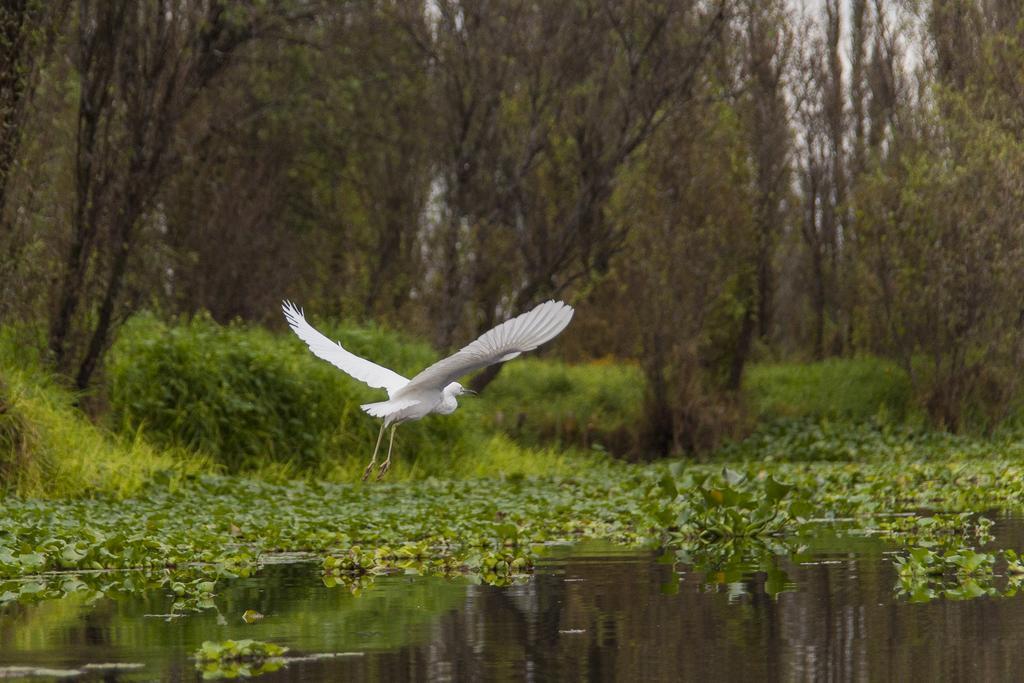Could you give a brief overview of what you see in this image? In this image we can see a bird is flying. There are trees in the background and leaves are there on the surface of water. 